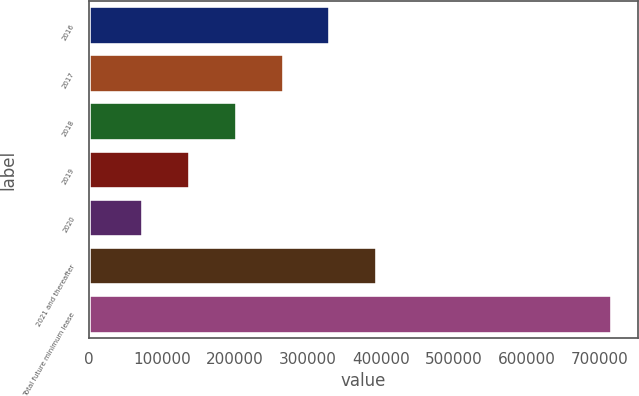<chart> <loc_0><loc_0><loc_500><loc_500><bar_chart><fcel>2016<fcel>2017<fcel>2018<fcel>2019<fcel>2020<fcel>2021 and thereafter<fcel>Total future minimum lease<nl><fcel>331114<fcel>266788<fcel>202461<fcel>138135<fcel>73808<fcel>395441<fcel>717074<nl></chart> 